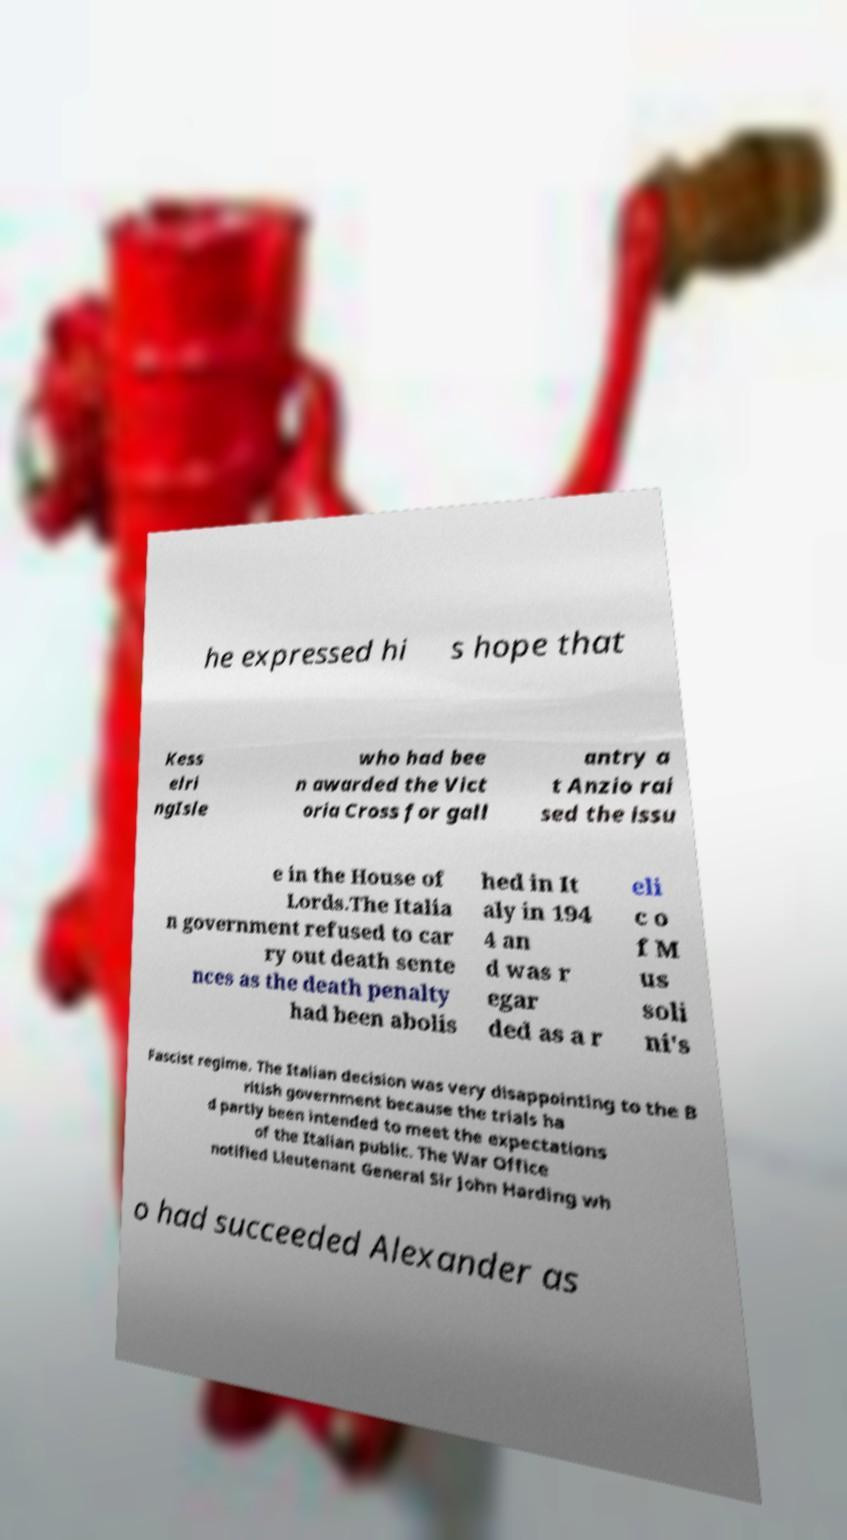What messages or text are displayed in this image? I need them in a readable, typed format. he expressed hi s hope that Kess elri ngIsle who had bee n awarded the Vict oria Cross for gall antry a t Anzio rai sed the issu e in the House of Lords.The Italia n government refused to car ry out death sente nces as the death penalty had been abolis hed in It aly in 194 4 an d was r egar ded as a r eli c o f M us soli ni's Fascist regime. The Italian decision was very disappointing to the B ritish government because the trials ha d partly been intended to meet the expectations of the Italian public. The War Office notified Lieutenant General Sir John Harding wh o had succeeded Alexander as 